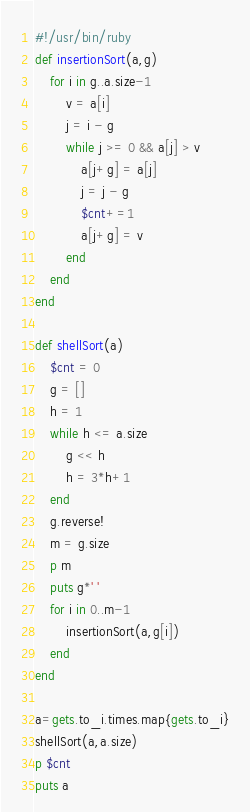Convert code to text. <code><loc_0><loc_0><loc_500><loc_500><_Ruby_>#!/usr/bin/ruby
def insertionSort(a,g)
	for i in g..a.size-1
		v = a[i]
		j = i - g
		while j >= 0 && a[j] > v
			a[j+g] = a[j]
			j = j - g
			$cnt+=1
			a[j+g] = v
		end
	end
end

def shellSort(a)
	$cnt = 0
	g = []
	h = 1
	while h <= a.size
		g << h
		h = 3*h+1
	end
	g.reverse!
	m = g.size
	p m
	puts g*' '
	for i in 0..m-1
		insertionSort(a,g[i])
	end
end

a=gets.to_i.times.map{gets.to_i}
shellSort(a,a.size)
p $cnt
puts a</code> 